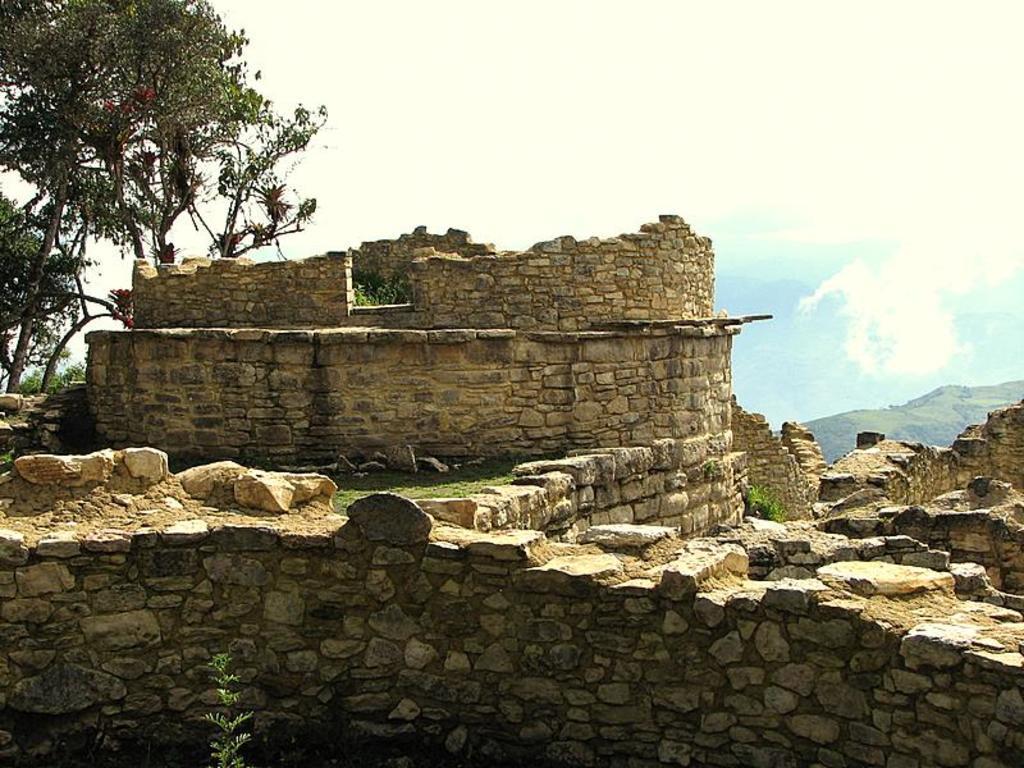How would you summarize this image in a sentence or two? In the center of the image, we can see a fort and there are rocks. In the background, there are trees. At the top, there is sky. 